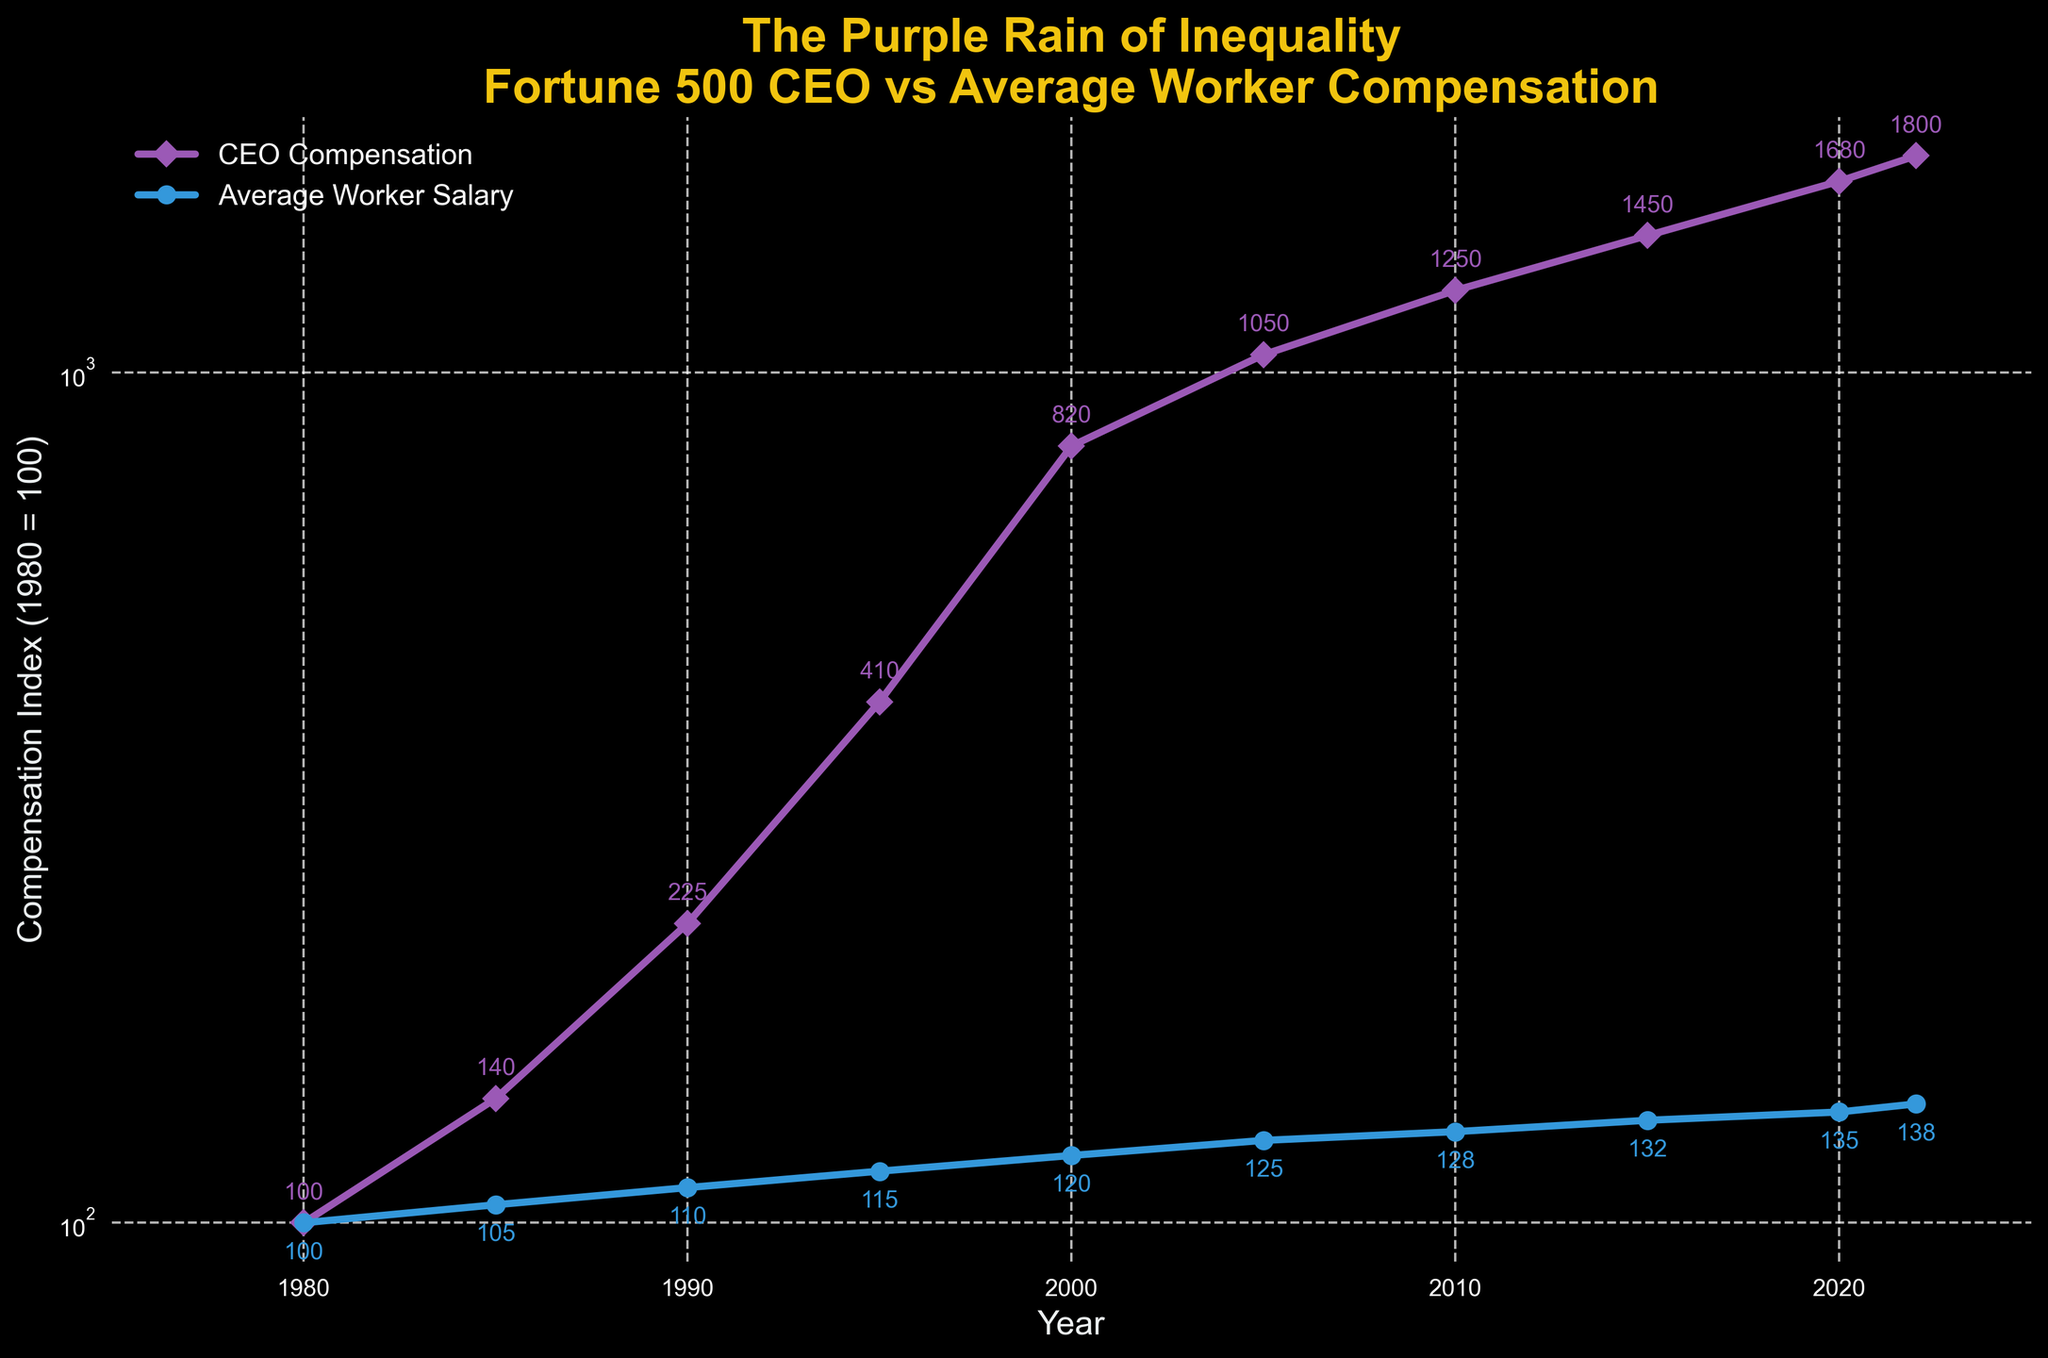what is the compensation index for CEOs in 1990? Look at the point where the CEO compensation line intersects the year 1990. The index value is labeled next to the marker.
Answer: 225 By how much did the CEO compensation index increase between 1980 and 2000? Find the CEO compensation index for both years, 1980 and 2000. Subtract the 1980 index from the 2000 index: 820 - 100 = 720
Answer: 720 Which year shows the largest difference between the CEO compensation index and the average worker salary index? Identify each year on the x-axis and the corresponding values of both indices. Subtract the average worker salary index from the CEO compensation index for each year and find the largest difference: 2022 has 1800 - 138 = 1662
Answer: 2022 What is the ratio of the CEO compensation index to the average worker salary index in 2015? Locate the values for both indices in 2015. Divide the CEO compensation index by the average worker salary index: 1450 / 132 = 10.98
Answer: 10.98 How has the average worker salary index changed from 1980 to 2022? Note the values for the average worker salary index in 1980 and 2022. Subtract the 1980 index from the 2022 index: 138 - 100 = 38
Answer: Increased by 38 Which index showed a more rapid growth from 1980 to 2022, CEO compensation or average worker salary? Compare the growth for both indices between 1980 and 2022 by subtracting their values for 1980 from 2022 (CEO: 1800 - 100 = 1700, Worker: 138 - 100 = 38) and see which difference is greater.
Answer: CEO compensation What do the colors of the lines represent in the plot? Check the color of each line and refer to the legend for the corresponding labels. The purple line represents CEO compensation, and the blue line represents the average worker salary index.
Answer: CEO compensation (purple), Average worker salary (blue) By what percentage did the CEO compensation index grow from 1985 to 1995? Calculate the percentage increase using the formula [(New Value - Old Value) / Old Value] * 100. For 1985 to 1995, it’s [(410 - 140) / 140] * 100 = 193.57%
Answer: 193.57% What visual feature distinguishes the CEO compensation line from the average worker salary line? Look at the visual attributes of both lines, their markers, and colors. The CEO compensation line uses diamond markers and is purple-colored, whereas the average worker salary line uses circle markers and is blue-colored.
Answer: The CEO line uses diamond markers and is purple In which year did the CEO compensation index first reach or exceed 1000? Identify the first point on the CEO compensation line that reaches or exceeds the 1000 mark. This occurs in 2005.
Answer: 2005 